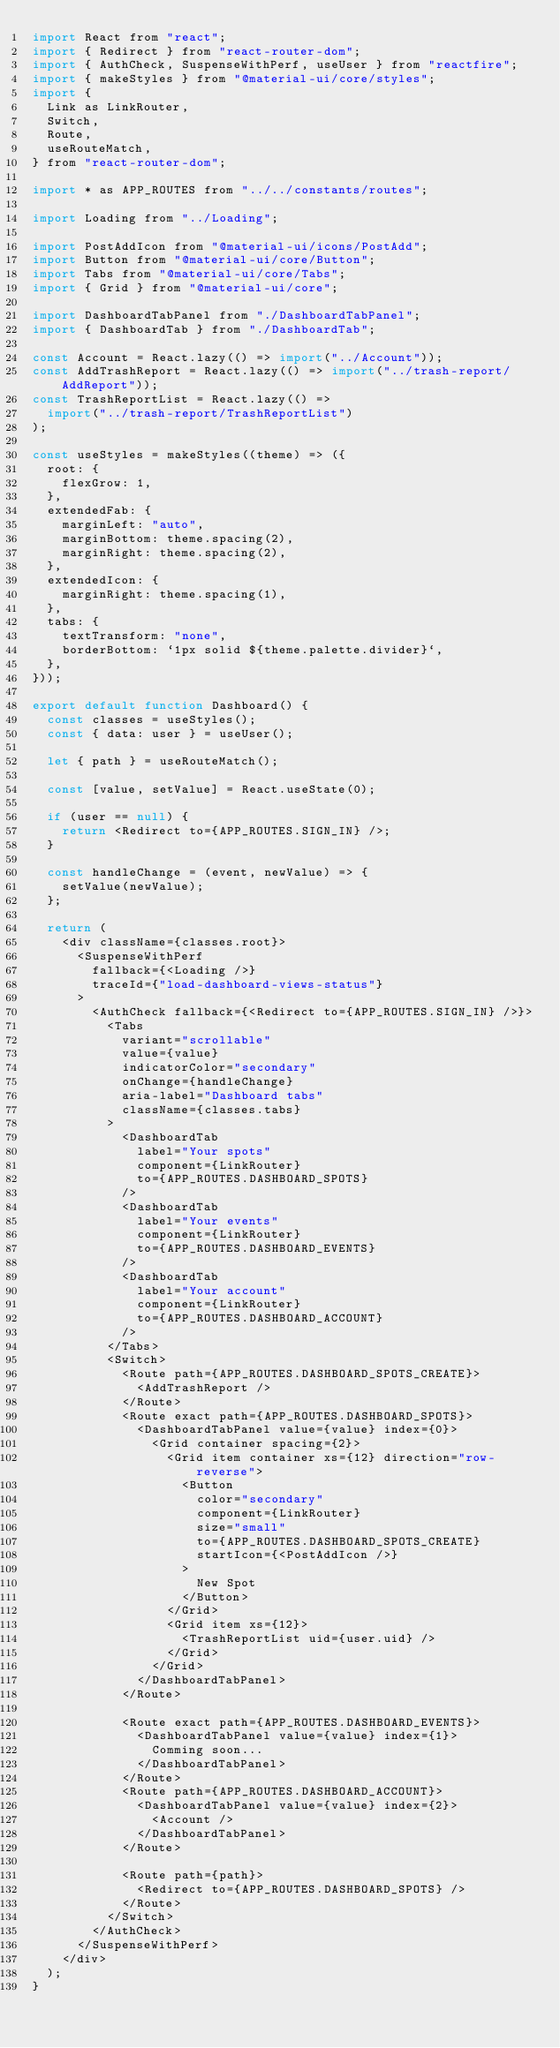Convert code to text. <code><loc_0><loc_0><loc_500><loc_500><_JavaScript_>import React from "react";
import { Redirect } from "react-router-dom";
import { AuthCheck, SuspenseWithPerf, useUser } from "reactfire";
import { makeStyles } from "@material-ui/core/styles";
import {
  Link as LinkRouter,
  Switch,
  Route,
  useRouteMatch,
} from "react-router-dom";

import * as APP_ROUTES from "../../constants/routes";

import Loading from "../Loading";

import PostAddIcon from "@material-ui/icons/PostAdd";
import Button from "@material-ui/core/Button";
import Tabs from "@material-ui/core/Tabs";
import { Grid } from "@material-ui/core";

import DashboardTabPanel from "./DashboardTabPanel";
import { DashboardTab } from "./DashboardTab";

const Account = React.lazy(() => import("../Account"));
const AddTrashReport = React.lazy(() => import("../trash-report/AddReport"));
const TrashReportList = React.lazy(() =>
  import("../trash-report/TrashReportList")
);

const useStyles = makeStyles((theme) => ({
  root: {
    flexGrow: 1,
  },
  extendedFab: {
    marginLeft: "auto",
    marginBottom: theme.spacing(2),
    marginRight: theme.spacing(2),
  },
  extendedIcon: {
    marginRight: theme.spacing(1),
  },
  tabs: {
    textTransform: "none",
    borderBottom: `1px solid ${theme.palette.divider}`,
  },
}));

export default function Dashboard() {
  const classes = useStyles();
  const { data: user } = useUser();

  let { path } = useRouteMatch();

  const [value, setValue] = React.useState(0);

  if (user == null) {
    return <Redirect to={APP_ROUTES.SIGN_IN} />;
  }

  const handleChange = (event, newValue) => {
    setValue(newValue);
  };

  return (
    <div className={classes.root}>
      <SuspenseWithPerf
        fallback={<Loading />}
        traceId={"load-dashboard-views-status"}
      >
        <AuthCheck fallback={<Redirect to={APP_ROUTES.SIGN_IN} />}>
          <Tabs
            variant="scrollable"
            value={value}
            indicatorColor="secondary"
            onChange={handleChange}
            aria-label="Dashboard tabs"
            className={classes.tabs}
          >
            <DashboardTab
              label="Your spots"
              component={LinkRouter}
              to={APP_ROUTES.DASHBOARD_SPOTS}
            />
            <DashboardTab
              label="Your events"
              component={LinkRouter}
              to={APP_ROUTES.DASHBOARD_EVENTS}
            />
            <DashboardTab
              label="Your account"
              component={LinkRouter}
              to={APP_ROUTES.DASHBOARD_ACCOUNT}
            />
          </Tabs>
          <Switch>
            <Route path={APP_ROUTES.DASHBOARD_SPOTS_CREATE}>
              <AddTrashReport />
            </Route>
            <Route exact path={APP_ROUTES.DASHBOARD_SPOTS}>
              <DashboardTabPanel value={value} index={0}>
                <Grid container spacing={2}>
                  <Grid item container xs={12} direction="row-reverse">
                    <Button
                      color="secondary"
                      component={LinkRouter}
                      size="small"
                      to={APP_ROUTES.DASHBOARD_SPOTS_CREATE}
                      startIcon={<PostAddIcon />}
                    >
                      New Spot
                    </Button>
                  </Grid>
                  <Grid item xs={12}>
                    <TrashReportList uid={user.uid} />
                  </Grid>
                </Grid>
              </DashboardTabPanel>
            </Route>

            <Route exact path={APP_ROUTES.DASHBOARD_EVENTS}>
              <DashboardTabPanel value={value} index={1}>
                Comming soon...
              </DashboardTabPanel>
            </Route>
            <Route path={APP_ROUTES.DASHBOARD_ACCOUNT}>
              <DashboardTabPanel value={value} index={2}>
                <Account />
              </DashboardTabPanel>
            </Route>

            <Route path={path}>
              <Redirect to={APP_ROUTES.DASHBOARD_SPOTS} />
            </Route>
          </Switch>
        </AuthCheck>
      </SuspenseWithPerf>
    </div>
  );
}
</code> 